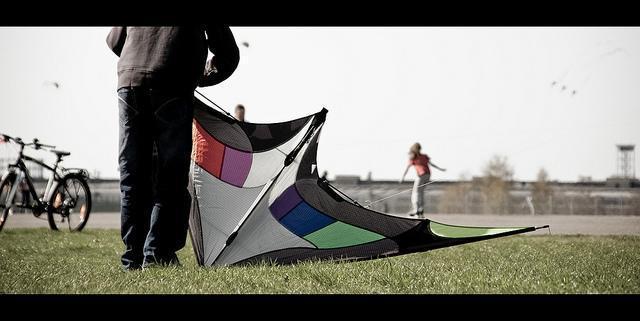How many recreational activities are represented here?
Give a very brief answer. 3. 